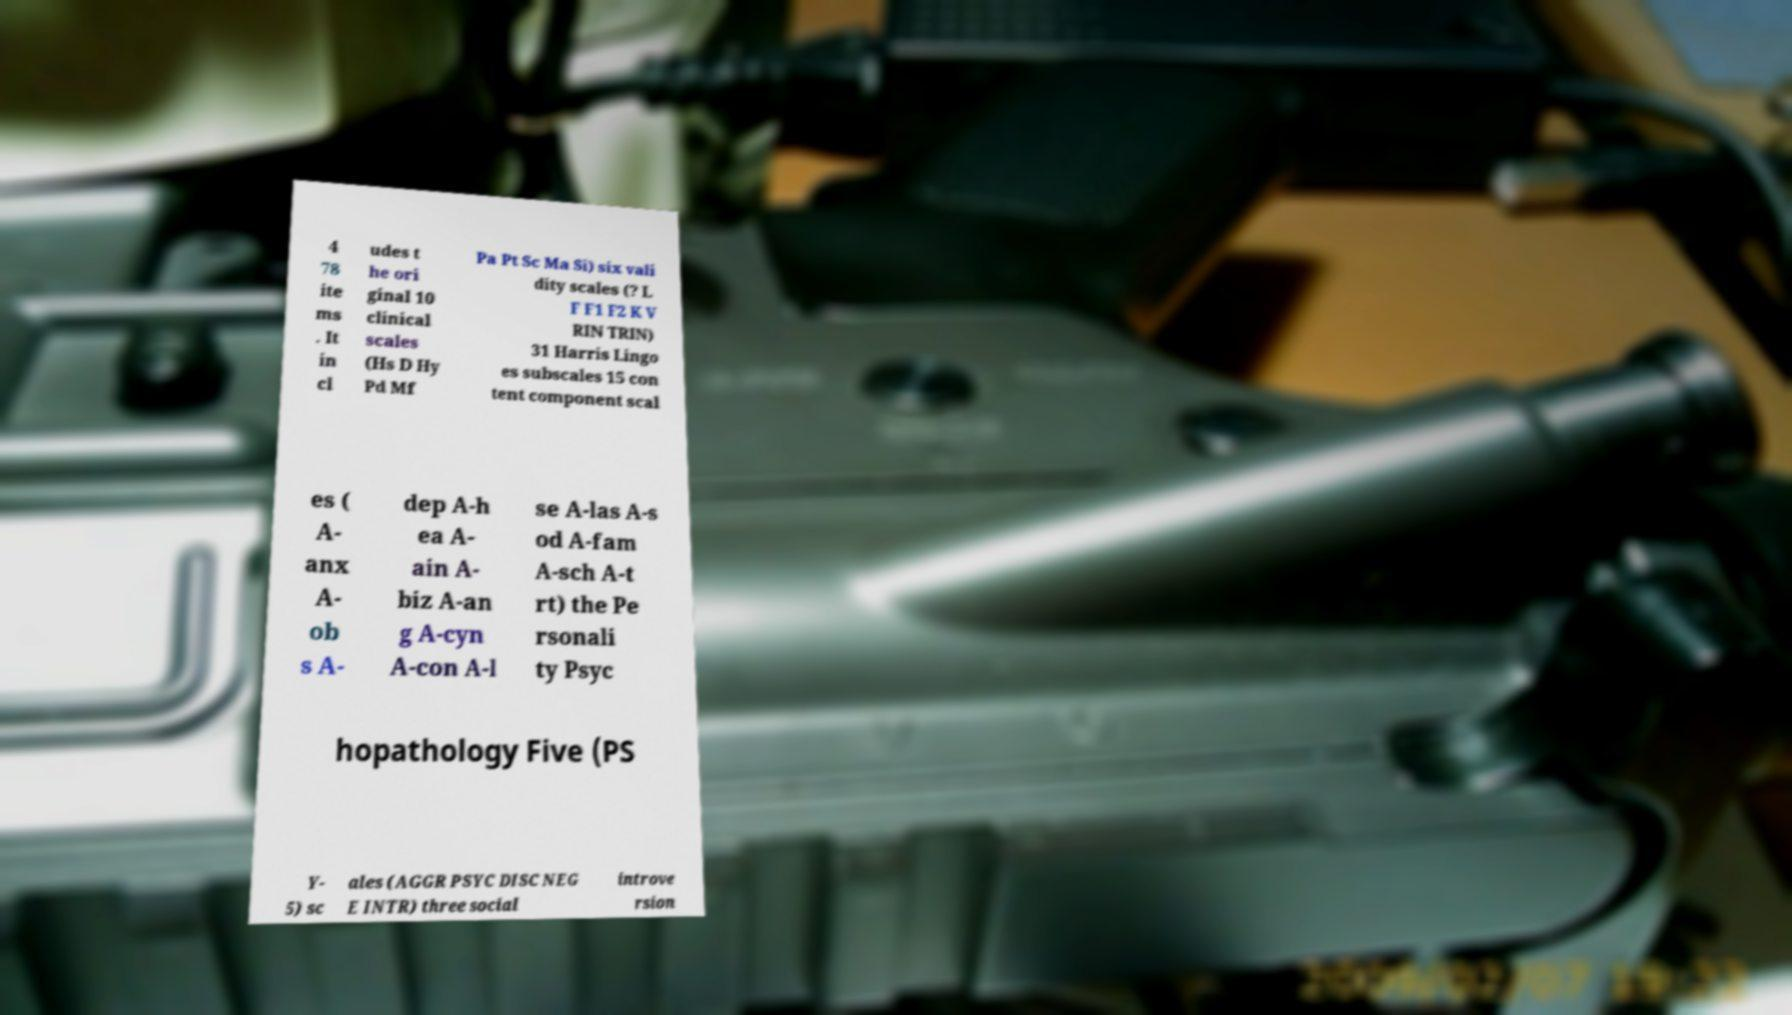There's text embedded in this image that I need extracted. Can you transcribe it verbatim? 4 78 ite ms . It in cl udes t he ori ginal 10 clinical scales (Hs D Hy Pd Mf Pa Pt Sc Ma Si) six vali dity scales (? L F F1 F2 K V RIN TRIN) 31 Harris Lingo es subscales 15 con tent component scal es ( A- anx A- ob s A- dep A-h ea A- ain A- biz A-an g A-cyn A-con A-l se A-las A-s od A-fam A-sch A-t rt) the Pe rsonali ty Psyc hopathology Five (PS Y- 5) sc ales (AGGR PSYC DISC NEG E INTR) three social introve rsion 